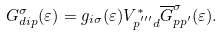Convert formula to latex. <formula><loc_0><loc_0><loc_500><loc_500>G _ { d i { p } } ^ { \sigma } ( \varepsilon ) = g _ { i \sigma } ( \varepsilon ) V _ { { p ^ { ^ { \prime \prime \prime } } } d } ^ { * } \overline { G } _ { p p ^ { \prime } } ^ { \sigma } ( \varepsilon ) .</formula> 